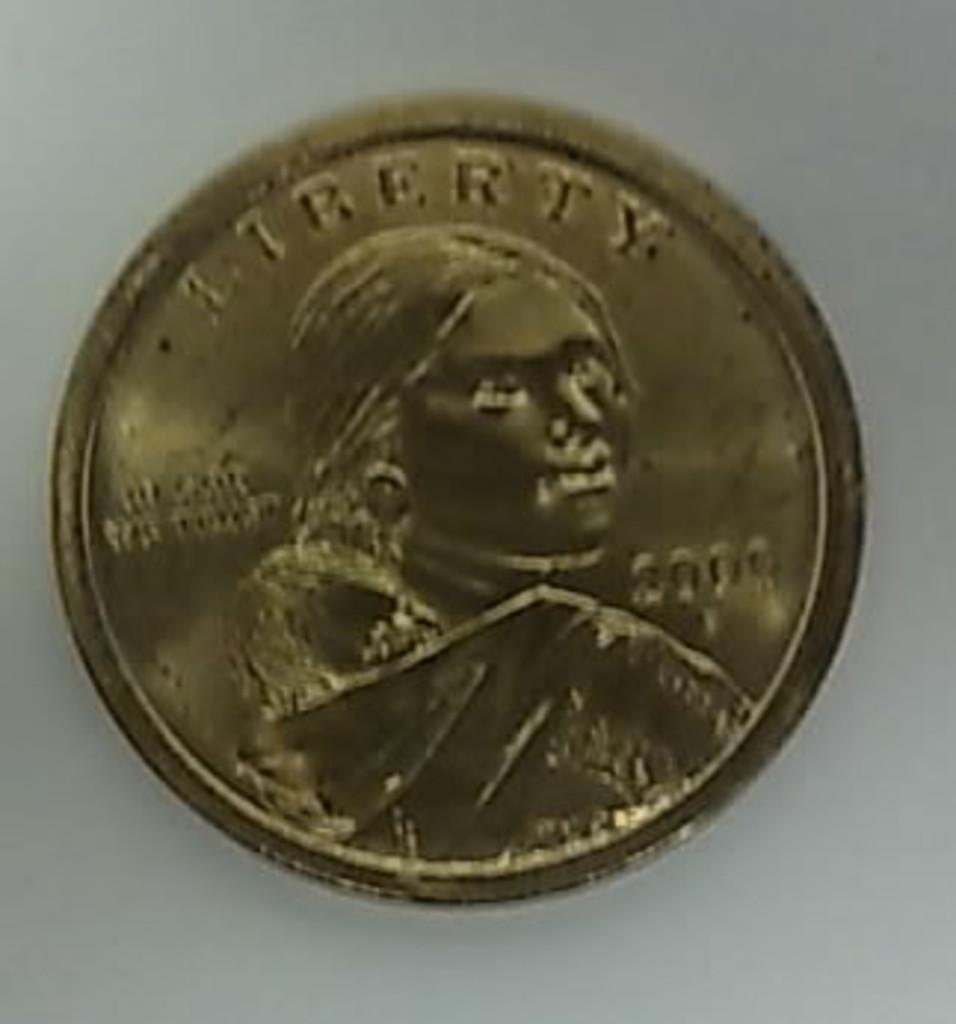<image>
Share a concise interpretation of the image provided. A Liberty coin has a picture of a woman on it. 